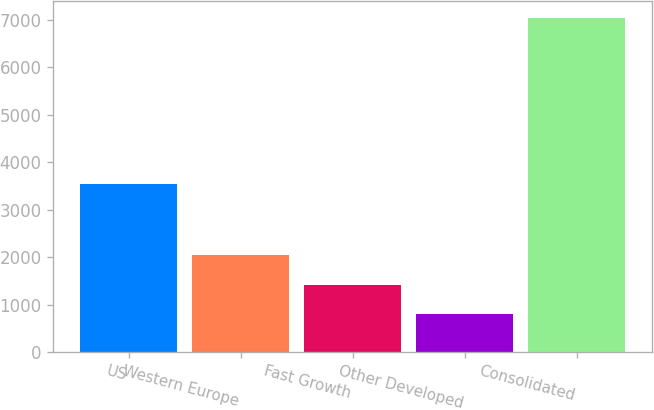<chart> <loc_0><loc_0><loc_500><loc_500><bar_chart><fcel>US<fcel>Western Europe<fcel>Fast Growth<fcel>Other Developed<fcel>Consolidated<nl><fcel>3541.1<fcel>2046.52<fcel>1422.46<fcel>798.4<fcel>7039<nl></chart> 